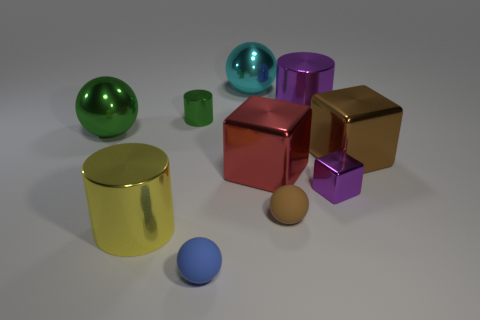How many objects are either yellow balls or purple metal objects?
Your answer should be compact. 2. Does the yellow metallic object have the same shape as the brown metallic thing?
Give a very brief answer. No. What material is the brown sphere?
Ensure brevity in your answer.  Rubber. How many large shiny things are in front of the large brown metal cube and to the right of the small blue ball?
Offer a terse response. 1. Do the purple metal block and the blue matte ball have the same size?
Offer a terse response. Yes. Do the brown ball right of the blue sphere and the blue ball have the same size?
Keep it short and to the point. Yes. What is the color of the big sphere behind the big purple object?
Ensure brevity in your answer.  Cyan. How many big green rubber blocks are there?
Your answer should be very brief. 0. What is the shape of the other thing that is made of the same material as the small blue thing?
Offer a terse response. Sphere. Do the big shiny block on the right side of the tiny brown rubber sphere and the matte thing right of the tiny blue object have the same color?
Your answer should be very brief. Yes. 